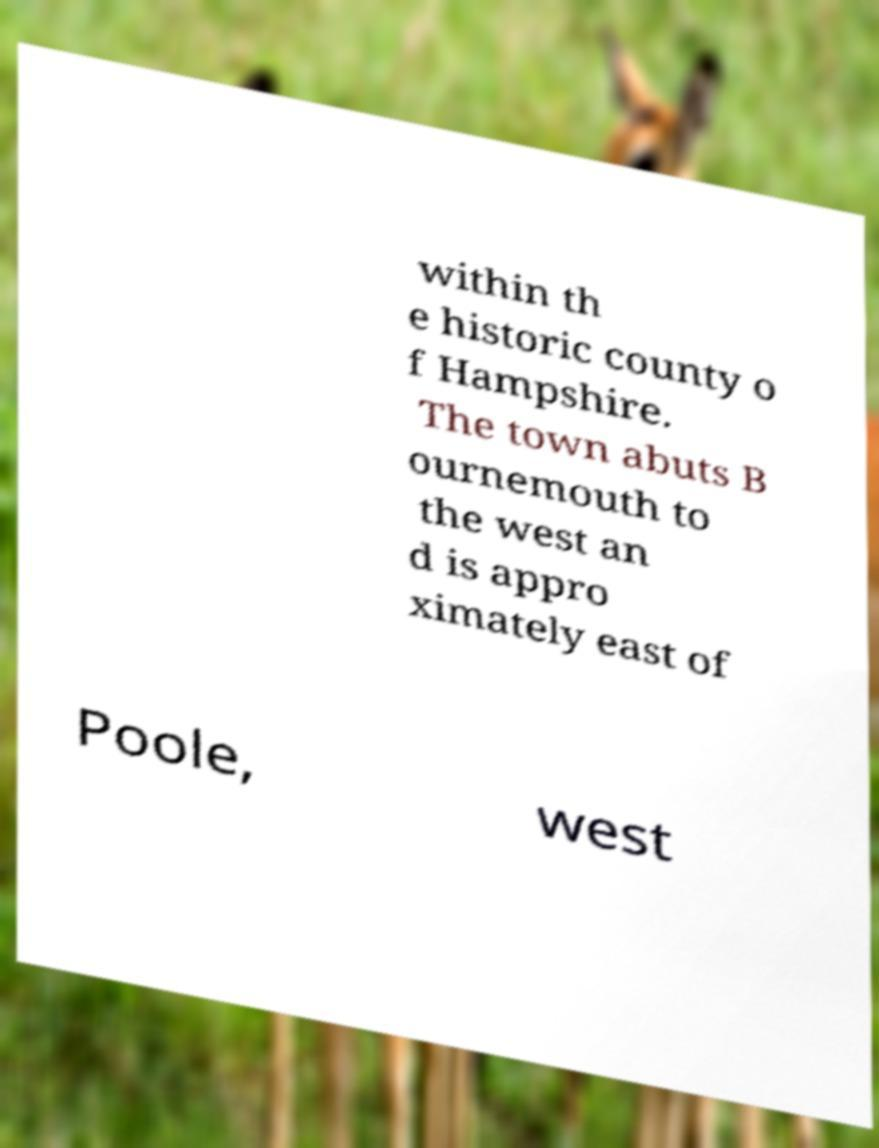Could you assist in decoding the text presented in this image and type it out clearly? within th e historic county o f Hampshire. The town abuts B ournemouth to the west an d is appro ximately east of Poole, west 